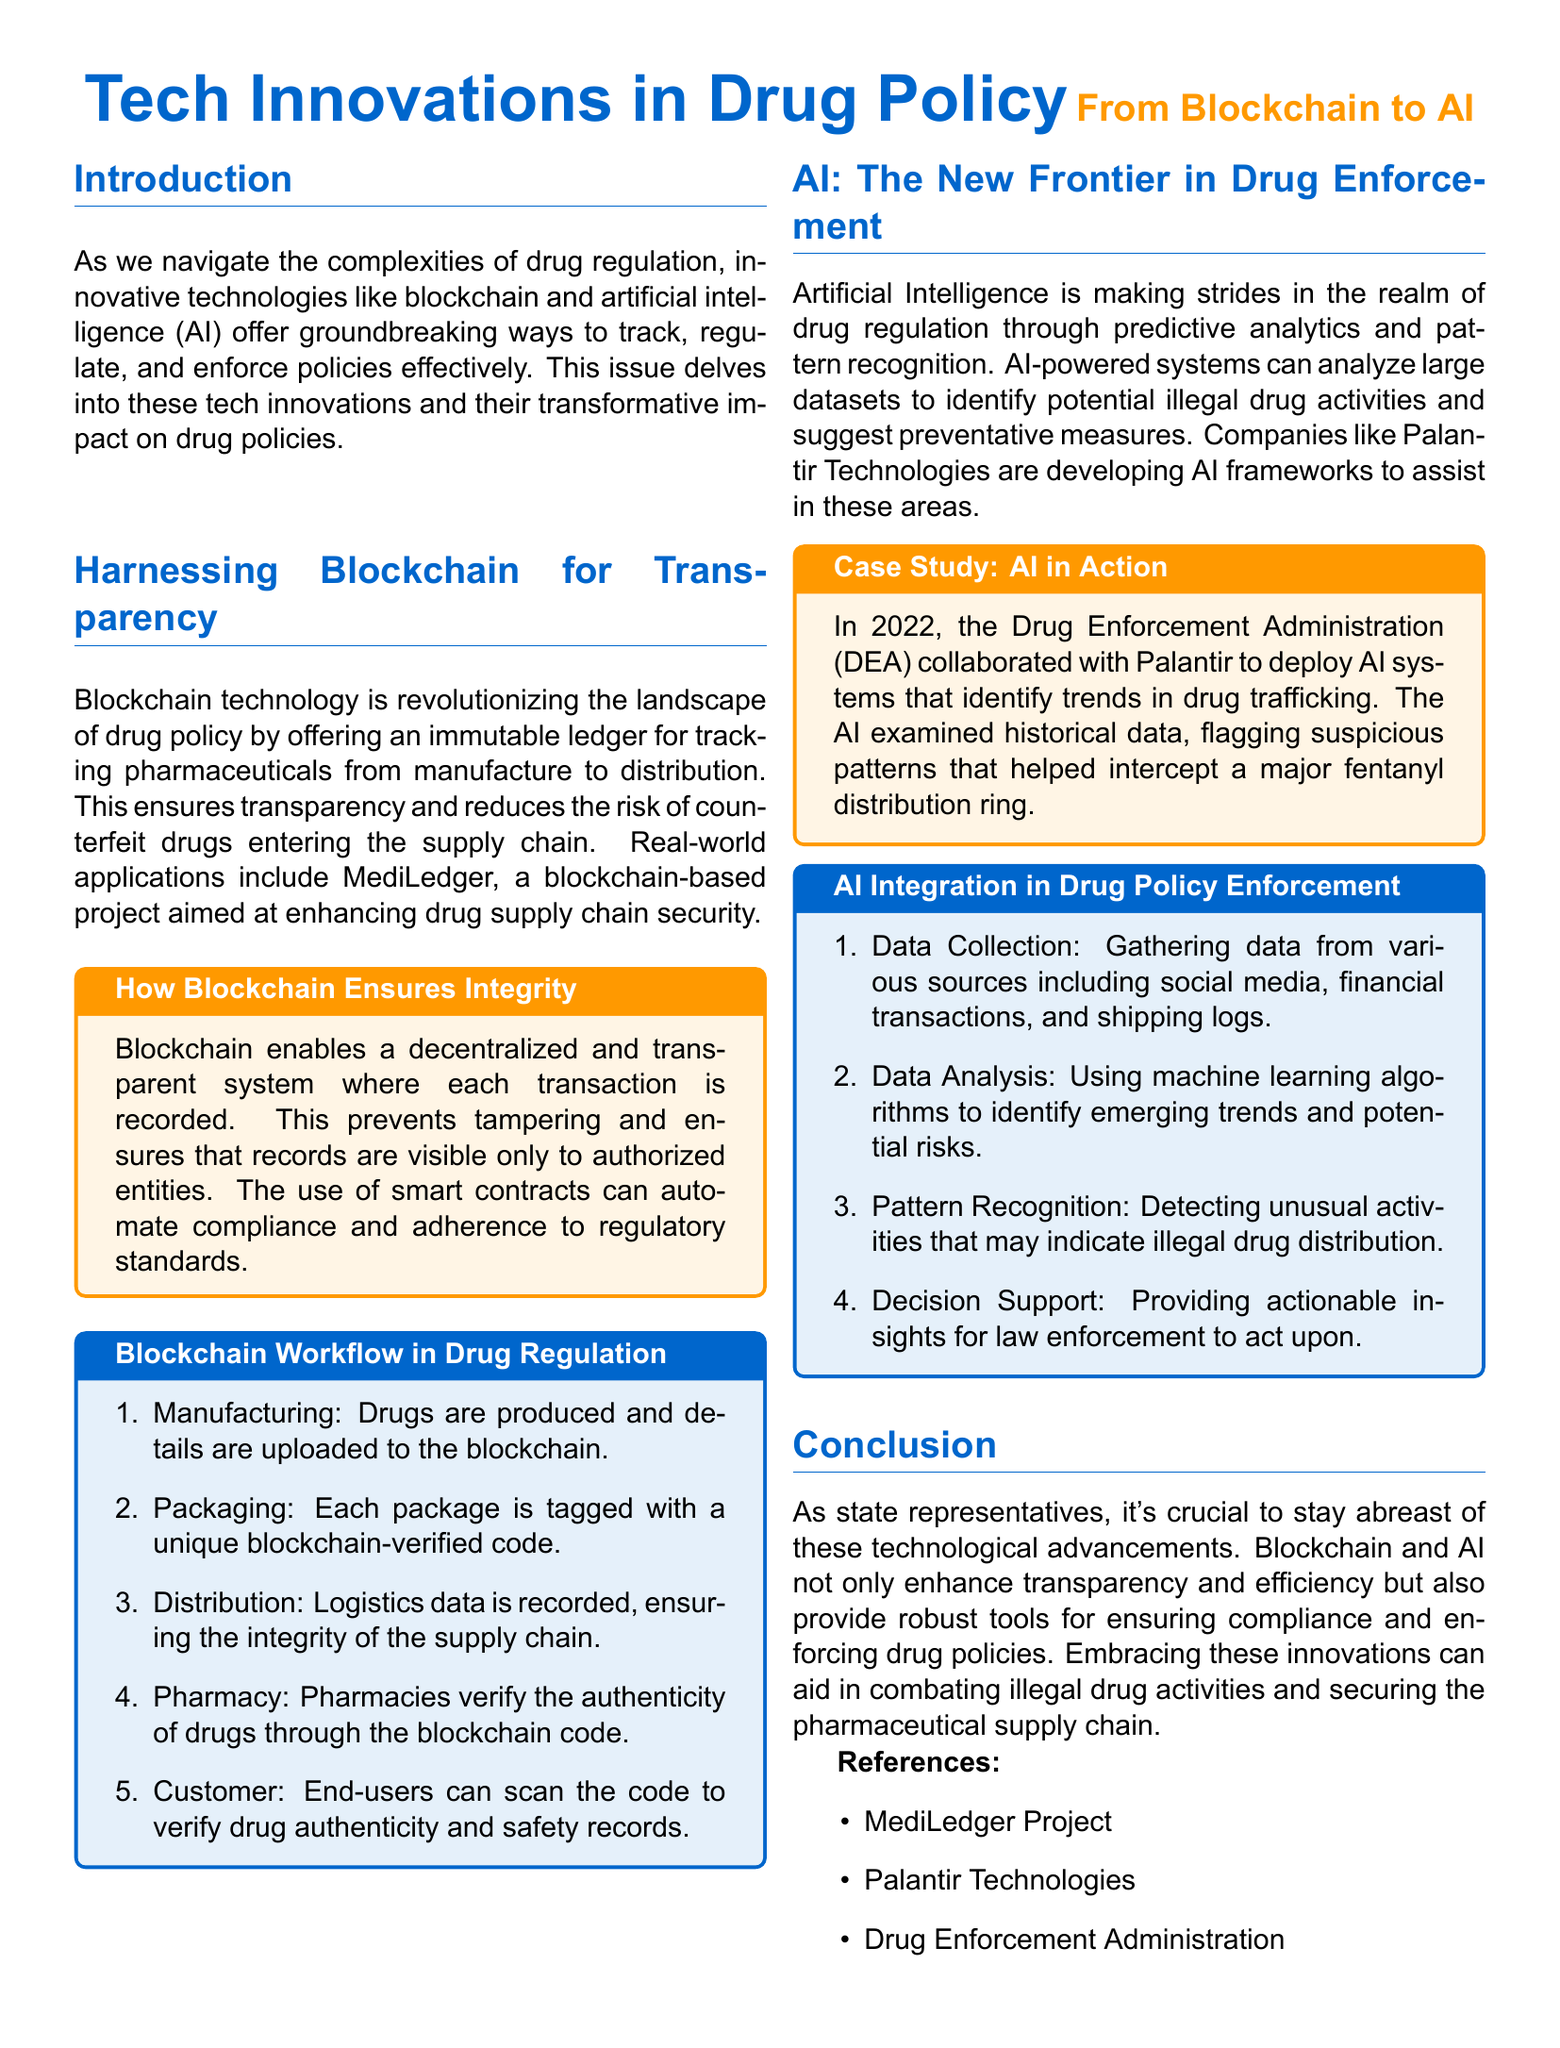What technology is revolutionizing drug policy? The document states that blockchain technology is revolutionizing the landscape of drug policy.
Answer: blockchain What project is mentioned as enhancing drug supply chain security? The document highlights MediLedger as a blockchain-based project for this purpose.
Answer: MediLedger In what year did the DEA collaborate with Palantir? The case study in the document mentions the year 2022 for the collaboration.
Answer: 2022 What type of analytics is AI primarily using for drug regulation? The document mentions that AI is making strides through predictive analytics.
Answer: predictive analytics What is the final step in the Blockchain Workflow in Drug Regulation? According to the document, the last step is that customers can scan the code to verify drug authenticity and safety records.
Answer: Customer: End-users can scan the code to verify drug authenticity and safety records What role does AI play in drug policy enforcement? The document states that AI provides actionable insights for law enforcement.
Answer: decision support What does the sidebar about blockchain focus on? The sidebar focuses on how blockchain ensures integrity in the drug supply chain.
Answer: How Blockchain Ensures Integrity What is the outcome of AI identifying trends in drug trafficking? The report indicates that the outcome helped intercept a major fentanyl distribution ring.
Answer: intercept a major fentanyl distribution ring 